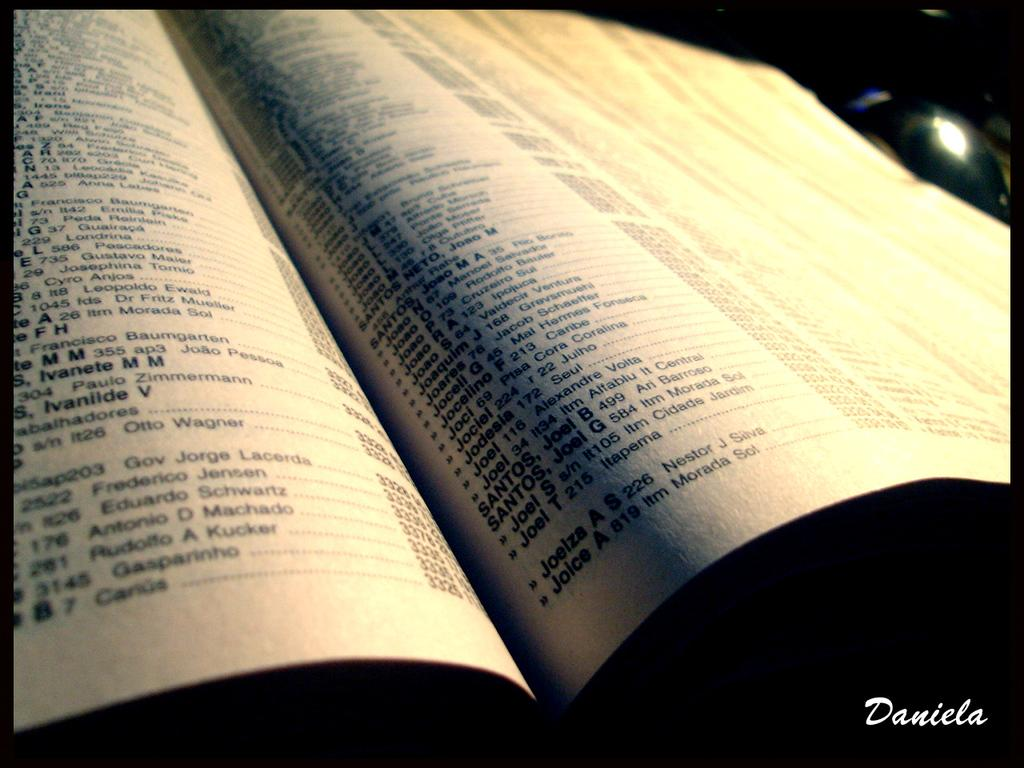<image>
Write a terse but informative summary of the picture. A phone book opened to pages of information not in English 